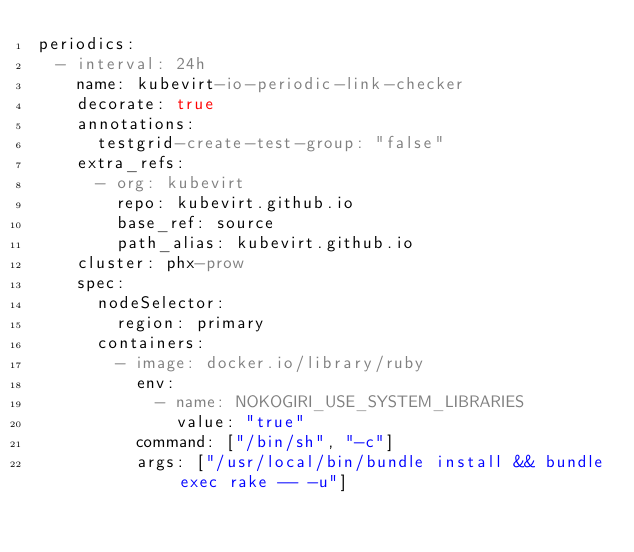Convert code to text. <code><loc_0><loc_0><loc_500><loc_500><_YAML_>periodics:
  - interval: 24h
    name: kubevirt-io-periodic-link-checker
    decorate: true
    annotations:
      testgrid-create-test-group: "false"
    extra_refs:
      - org: kubevirt
        repo: kubevirt.github.io
        base_ref: source
        path_alias: kubevirt.github.io
    cluster: phx-prow
    spec:
      nodeSelector:
        region: primary
      containers:
        - image: docker.io/library/ruby
          env:
            - name: NOKOGIRI_USE_SYSTEM_LIBRARIES
              value: "true"
          command: ["/bin/sh", "-c"]
          args: ["/usr/local/bin/bundle install && bundle exec rake -- -u"]
</code> 